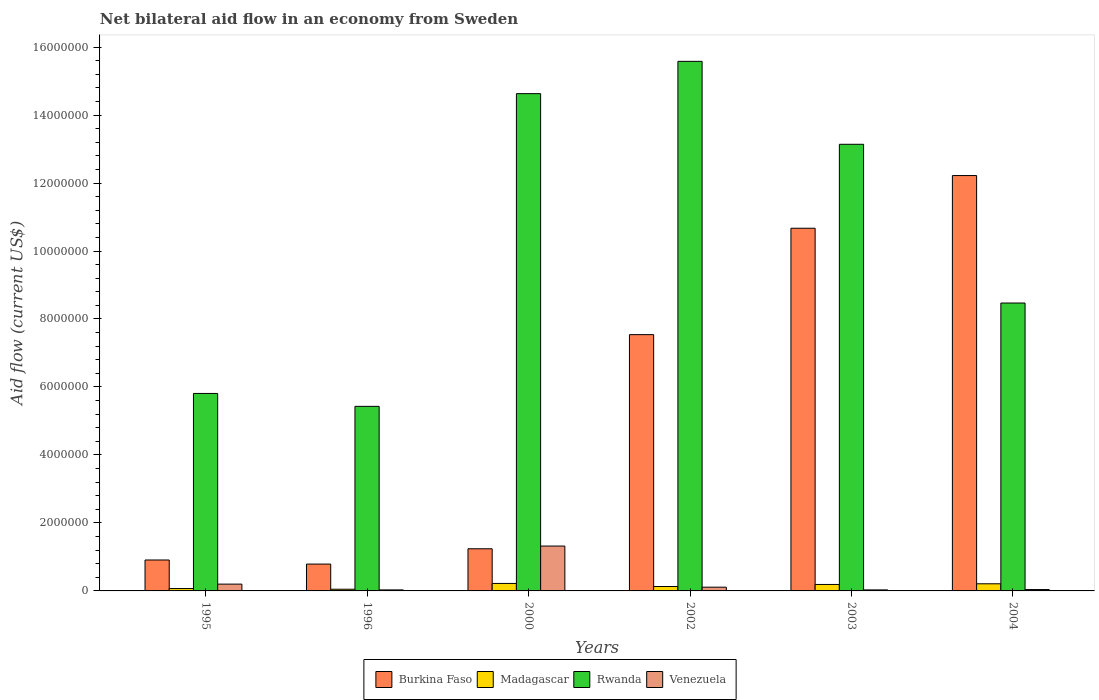How many groups of bars are there?
Provide a short and direct response. 6. Are the number of bars per tick equal to the number of legend labels?
Keep it short and to the point. Yes. Are the number of bars on each tick of the X-axis equal?
Your answer should be compact. Yes. What is the label of the 2nd group of bars from the left?
Your response must be concise. 1996. What is the net bilateral aid flow in Rwanda in 1995?
Your answer should be compact. 5.81e+06. Across all years, what is the maximum net bilateral aid flow in Venezuela?
Keep it short and to the point. 1.32e+06. Across all years, what is the minimum net bilateral aid flow in Rwanda?
Make the answer very short. 5.43e+06. In which year was the net bilateral aid flow in Madagascar maximum?
Your response must be concise. 2000. What is the total net bilateral aid flow in Burkina Faso in the graph?
Provide a succinct answer. 3.34e+07. What is the difference between the net bilateral aid flow in Venezuela in 2002 and that in 2003?
Your answer should be very brief. 8.00e+04. What is the difference between the net bilateral aid flow in Rwanda in 1996 and the net bilateral aid flow in Venezuela in 1995?
Offer a terse response. 5.23e+06. What is the average net bilateral aid flow in Venezuela per year?
Make the answer very short. 2.88e+05. In the year 2000, what is the difference between the net bilateral aid flow in Rwanda and net bilateral aid flow in Venezuela?
Keep it short and to the point. 1.33e+07. What is the ratio of the net bilateral aid flow in Madagascar in 1996 to that in 2000?
Make the answer very short. 0.23. Is the difference between the net bilateral aid flow in Rwanda in 1996 and 2003 greater than the difference between the net bilateral aid flow in Venezuela in 1996 and 2003?
Keep it short and to the point. No. What is the difference between the highest and the second highest net bilateral aid flow in Rwanda?
Offer a terse response. 9.50e+05. What is the difference between the highest and the lowest net bilateral aid flow in Madagascar?
Keep it short and to the point. 1.70e+05. What does the 2nd bar from the left in 2004 represents?
Your answer should be very brief. Madagascar. What does the 3rd bar from the right in 2002 represents?
Provide a short and direct response. Madagascar. Are all the bars in the graph horizontal?
Make the answer very short. No. What is the difference between two consecutive major ticks on the Y-axis?
Offer a terse response. 2.00e+06. Are the values on the major ticks of Y-axis written in scientific E-notation?
Your answer should be compact. No. Does the graph contain grids?
Offer a terse response. No. Where does the legend appear in the graph?
Your answer should be very brief. Bottom center. How are the legend labels stacked?
Offer a very short reply. Horizontal. What is the title of the graph?
Offer a very short reply. Net bilateral aid flow in an economy from Sweden. Does "World" appear as one of the legend labels in the graph?
Offer a very short reply. No. What is the label or title of the X-axis?
Make the answer very short. Years. What is the label or title of the Y-axis?
Provide a succinct answer. Aid flow (current US$). What is the Aid flow (current US$) of Burkina Faso in 1995?
Your response must be concise. 9.10e+05. What is the Aid flow (current US$) of Rwanda in 1995?
Your answer should be compact. 5.81e+06. What is the Aid flow (current US$) in Burkina Faso in 1996?
Provide a short and direct response. 7.90e+05. What is the Aid flow (current US$) of Rwanda in 1996?
Your answer should be very brief. 5.43e+06. What is the Aid flow (current US$) of Venezuela in 1996?
Your answer should be compact. 3.00e+04. What is the Aid flow (current US$) in Burkina Faso in 2000?
Ensure brevity in your answer.  1.24e+06. What is the Aid flow (current US$) in Madagascar in 2000?
Give a very brief answer. 2.20e+05. What is the Aid flow (current US$) of Rwanda in 2000?
Your answer should be very brief. 1.46e+07. What is the Aid flow (current US$) of Venezuela in 2000?
Offer a very short reply. 1.32e+06. What is the Aid flow (current US$) in Burkina Faso in 2002?
Your response must be concise. 7.54e+06. What is the Aid flow (current US$) of Rwanda in 2002?
Your answer should be very brief. 1.56e+07. What is the Aid flow (current US$) in Venezuela in 2002?
Offer a very short reply. 1.10e+05. What is the Aid flow (current US$) of Burkina Faso in 2003?
Ensure brevity in your answer.  1.07e+07. What is the Aid flow (current US$) of Rwanda in 2003?
Make the answer very short. 1.31e+07. What is the Aid flow (current US$) of Venezuela in 2003?
Provide a succinct answer. 3.00e+04. What is the Aid flow (current US$) of Burkina Faso in 2004?
Your answer should be compact. 1.22e+07. What is the Aid flow (current US$) of Madagascar in 2004?
Offer a terse response. 2.10e+05. What is the Aid flow (current US$) in Rwanda in 2004?
Provide a short and direct response. 8.47e+06. What is the Aid flow (current US$) in Venezuela in 2004?
Offer a very short reply. 4.00e+04. Across all years, what is the maximum Aid flow (current US$) of Burkina Faso?
Keep it short and to the point. 1.22e+07. Across all years, what is the maximum Aid flow (current US$) of Madagascar?
Keep it short and to the point. 2.20e+05. Across all years, what is the maximum Aid flow (current US$) of Rwanda?
Make the answer very short. 1.56e+07. Across all years, what is the maximum Aid flow (current US$) of Venezuela?
Your response must be concise. 1.32e+06. Across all years, what is the minimum Aid flow (current US$) in Burkina Faso?
Provide a succinct answer. 7.90e+05. Across all years, what is the minimum Aid flow (current US$) of Rwanda?
Offer a very short reply. 5.43e+06. What is the total Aid flow (current US$) in Burkina Faso in the graph?
Offer a very short reply. 3.34e+07. What is the total Aid flow (current US$) in Madagascar in the graph?
Provide a short and direct response. 8.70e+05. What is the total Aid flow (current US$) of Rwanda in the graph?
Offer a terse response. 6.31e+07. What is the total Aid flow (current US$) in Venezuela in the graph?
Ensure brevity in your answer.  1.73e+06. What is the difference between the Aid flow (current US$) in Burkina Faso in 1995 and that in 1996?
Provide a succinct answer. 1.20e+05. What is the difference between the Aid flow (current US$) in Venezuela in 1995 and that in 1996?
Offer a terse response. 1.70e+05. What is the difference between the Aid flow (current US$) in Burkina Faso in 1995 and that in 2000?
Ensure brevity in your answer.  -3.30e+05. What is the difference between the Aid flow (current US$) in Rwanda in 1995 and that in 2000?
Offer a terse response. -8.82e+06. What is the difference between the Aid flow (current US$) of Venezuela in 1995 and that in 2000?
Provide a succinct answer. -1.12e+06. What is the difference between the Aid flow (current US$) in Burkina Faso in 1995 and that in 2002?
Your answer should be compact. -6.63e+06. What is the difference between the Aid flow (current US$) in Rwanda in 1995 and that in 2002?
Your response must be concise. -9.77e+06. What is the difference between the Aid flow (current US$) in Burkina Faso in 1995 and that in 2003?
Provide a succinct answer. -9.76e+06. What is the difference between the Aid flow (current US$) of Madagascar in 1995 and that in 2003?
Ensure brevity in your answer.  -1.20e+05. What is the difference between the Aid flow (current US$) in Rwanda in 1995 and that in 2003?
Ensure brevity in your answer.  -7.33e+06. What is the difference between the Aid flow (current US$) of Burkina Faso in 1995 and that in 2004?
Your answer should be very brief. -1.13e+07. What is the difference between the Aid flow (current US$) of Rwanda in 1995 and that in 2004?
Offer a terse response. -2.66e+06. What is the difference between the Aid flow (current US$) in Venezuela in 1995 and that in 2004?
Provide a succinct answer. 1.60e+05. What is the difference between the Aid flow (current US$) in Burkina Faso in 1996 and that in 2000?
Offer a terse response. -4.50e+05. What is the difference between the Aid flow (current US$) of Rwanda in 1996 and that in 2000?
Give a very brief answer. -9.20e+06. What is the difference between the Aid flow (current US$) of Venezuela in 1996 and that in 2000?
Your response must be concise. -1.29e+06. What is the difference between the Aid flow (current US$) of Burkina Faso in 1996 and that in 2002?
Offer a terse response. -6.75e+06. What is the difference between the Aid flow (current US$) of Madagascar in 1996 and that in 2002?
Offer a very short reply. -8.00e+04. What is the difference between the Aid flow (current US$) in Rwanda in 1996 and that in 2002?
Ensure brevity in your answer.  -1.02e+07. What is the difference between the Aid flow (current US$) in Venezuela in 1996 and that in 2002?
Provide a short and direct response. -8.00e+04. What is the difference between the Aid flow (current US$) of Burkina Faso in 1996 and that in 2003?
Give a very brief answer. -9.88e+06. What is the difference between the Aid flow (current US$) of Madagascar in 1996 and that in 2003?
Provide a short and direct response. -1.40e+05. What is the difference between the Aid flow (current US$) of Rwanda in 1996 and that in 2003?
Provide a short and direct response. -7.71e+06. What is the difference between the Aid flow (current US$) in Venezuela in 1996 and that in 2003?
Offer a very short reply. 0. What is the difference between the Aid flow (current US$) in Burkina Faso in 1996 and that in 2004?
Keep it short and to the point. -1.14e+07. What is the difference between the Aid flow (current US$) in Rwanda in 1996 and that in 2004?
Provide a succinct answer. -3.04e+06. What is the difference between the Aid flow (current US$) of Burkina Faso in 2000 and that in 2002?
Ensure brevity in your answer.  -6.30e+06. What is the difference between the Aid flow (current US$) in Madagascar in 2000 and that in 2002?
Keep it short and to the point. 9.00e+04. What is the difference between the Aid flow (current US$) in Rwanda in 2000 and that in 2002?
Provide a short and direct response. -9.50e+05. What is the difference between the Aid flow (current US$) of Venezuela in 2000 and that in 2002?
Offer a very short reply. 1.21e+06. What is the difference between the Aid flow (current US$) of Burkina Faso in 2000 and that in 2003?
Keep it short and to the point. -9.43e+06. What is the difference between the Aid flow (current US$) of Madagascar in 2000 and that in 2003?
Give a very brief answer. 3.00e+04. What is the difference between the Aid flow (current US$) in Rwanda in 2000 and that in 2003?
Make the answer very short. 1.49e+06. What is the difference between the Aid flow (current US$) of Venezuela in 2000 and that in 2003?
Your answer should be very brief. 1.29e+06. What is the difference between the Aid flow (current US$) in Burkina Faso in 2000 and that in 2004?
Provide a short and direct response. -1.10e+07. What is the difference between the Aid flow (current US$) in Madagascar in 2000 and that in 2004?
Your answer should be very brief. 10000. What is the difference between the Aid flow (current US$) in Rwanda in 2000 and that in 2004?
Keep it short and to the point. 6.16e+06. What is the difference between the Aid flow (current US$) of Venezuela in 2000 and that in 2004?
Make the answer very short. 1.28e+06. What is the difference between the Aid flow (current US$) in Burkina Faso in 2002 and that in 2003?
Offer a very short reply. -3.13e+06. What is the difference between the Aid flow (current US$) of Rwanda in 2002 and that in 2003?
Your answer should be compact. 2.44e+06. What is the difference between the Aid flow (current US$) of Burkina Faso in 2002 and that in 2004?
Offer a very short reply. -4.68e+06. What is the difference between the Aid flow (current US$) in Madagascar in 2002 and that in 2004?
Your answer should be compact. -8.00e+04. What is the difference between the Aid flow (current US$) of Rwanda in 2002 and that in 2004?
Provide a short and direct response. 7.11e+06. What is the difference between the Aid flow (current US$) of Burkina Faso in 2003 and that in 2004?
Make the answer very short. -1.55e+06. What is the difference between the Aid flow (current US$) of Madagascar in 2003 and that in 2004?
Ensure brevity in your answer.  -2.00e+04. What is the difference between the Aid flow (current US$) in Rwanda in 2003 and that in 2004?
Provide a short and direct response. 4.67e+06. What is the difference between the Aid flow (current US$) of Burkina Faso in 1995 and the Aid flow (current US$) of Madagascar in 1996?
Offer a terse response. 8.60e+05. What is the difference between the Aid flow (current US$) of Burkina Faso in 1995 and the Aid flow (current US$) of Rwanda in 1996?
Your answer should be very brief. -4.52e+06. What is the difference between the Aid flow (current US$) of Burkina Faso in 1995 and the Aid flow (current US$) of Venezuela in 1996?
Your answer should be compact. 8.80e+05. What is the difference between the Aid flow (current US$) of Madagascar in 1995 and the Aid flow (current US$) of Rwanda in 1996?
Provide a succinct answer. -5.36e+06. What is the difference between the Aid flow (current US$) of Rwanda in 1995 and the Aid flow (current US$) of Venezuela in 1996?
Provide a short and direct response. 5.78e+06. What is the difference between the Aid flow (current US$) of Burkina Faso in 1995 and the Aid flow (current US$) of Madagascar in 2000?
Provide a succinct answer. 6.90e+05. What is the difference between the Aid flow (current US$) in Burkina Faso in 1995 and the Aid flow (current US$) in Rwanda in 2000?
Your answer should be very brief. -1.37e+07. What is the difference between the Aid flow (current US$) of Burkina Faso in 1995 and the Aid flow (current US$) of Venezuela in 2000?
Your response must be concise. -4.10e+05. What is the difference between the Aid flow (current US$) in Madagascar in 1995 and the Aid flow (current US$) in Rwanda in 2000?
Give a very brief answer. -1.46e+07. What is the difference between the Aid flow (current US$) of Madagascar in 1995 and the Aid flow (current US$) of Venezuela in 2000?
Provide a succinct answer. -1.25e+06. What is the difference between the Aid flow (current US$) in Rwanda in 1995 and the Aid flow (current US$) in Venezuela in 2000?
Your answer should be compact. 4.49e+06. What is the difference between the Aid flow (current US$) in Burkina Faso in 1995 and the Aid flow (current US$) in Madagascar in 2002?
Offer a terse response. 7.80e+05. What is the difference between the Aid flow (current US$) in Burkina Faso in 1995 and the Aid flow (current US$) in Rwanda in 2002?
Provide a short and direct response. -1.47e+07. What is the difference between the Aid flow (current US$) of Madagascar in 1995 and the Aid flow (current US$) of Rwanda in 2002?
Keep it short and to the point. -1.55e+07. What is the difference between the Aid flow (current US$) in Madagascar in 1995 and the Aid flow (current US$) in Venezuela in 2002?
Make the answer very short. -4.00e+04. What is the difference between the Aid flow (current US$) of Rwanda in 1995 and the Aid flow (current US$) of Venezuela in 2002?
Ensure brevity in your answer.  5.70e+06. What is the difference between the Aid flow (current US$) of Burkina Faso in 1995 and the Aid flow (current US$) of Madagascar in 2003?
Your answer should be compact. 7.20e+05. What is the difference between the Aid flow (current US$) in Burkina Faso in 1995 and the Aid flow (current US$) in Rwanda in 2003?
Provide a succinct answer. -1.22e+07. What is the difference between the Aid flow (current US$) of Burkina Faso in 1995 and the Aid flow (current US$) of Venezuela in 2003?
Your response must be concise. 8.80e+05. What is the difference between the Aid flow (current US$) in Madagascar in 1995 and the Aid flow (current US$) in Rwanda in 2003?
Give a very brief answer. -1.31e+07. What is the difference between the Aid flow (current US$) in Madagascar in 1995 and the Aid flow (current US$) in Venezuela in 2003?
Your answer should be very brief. 4.00e+04. What is the difference between the Aid flow (current US$) in Rwanda in 1995 and the Aid flow (current US$) in Venezuela in 2003?
Your answer should be compact. 5.78e+06. What is the difference between the Aid flow (current US$) of Burkina Faso in 1995 and the Aid flow (current US$) of Madagascar in 2004?
Offer a terse response. 7.00e+05. What is the difference between the Aid flow (current US$) in Burkina Faso in 1995 and the Aid flow (current US$) in Rwanda in 2004?
Give a very brief answer. -7.56e+06. What is the difference between the Aid flow (current US$) in Burkina Faso in 1995 and the Aid flow (current US$) in Venezuela in 2004?
Give a very brief answer. 8.70e+05. What is the difference between the Aid flow (current US$) of Madagascar in 1995 and the Aid flow (current US$) of Rwanda in 2004?
Keep it short and to the point. -8.40e+06. What is the difference between the Aid flow (current US$) in Madagascar in 1995 and the Aid flow (current US$) in Venezuela in 2004?
Provide a succinct answer. 3.00e+04. What is the difference between the Aid flow (current US$) of Rwanda in 1995 and the Aid flow (current US$) of Venezuela in 2004?
Your answer should be very brief. 5.77e+06. What is the difference between the Aid flow (current US$) of Burkina Faso in 1996 and the Aid flow (current US$) of Madagascar in 2000?
Your answer should be compact. 5.70e+05. What is the difference between the Aid flow (current US$) in Burkina Faso in 1996 and the Aid flow (current US$) in Rwanda in 2000?
Keep it short and to the point. -1.38e+07. What is the difference between the Aid flow (current US$) in Burkina Faso in 1996 and the Aid flow (current US$) in Venezuela in 2000?
Provide a short and direct response. -5.30e+05. What is the difference between the Aid flow (current US$) in Madagascar in 1996 and the Aid flow (current US$) in Rwanda in 2000?
Make the answer very short. -1.46e+07. What is the difference between the Aid flow (current US$) in Madagascar in 1996 and the Aid flow (current US$) in Venezuela in 2000?
Offer a very short reply. -1.27e+06. What is the difference between the Aid flow (current US$) in Rwanda in 1996 and the Aid flow (current US$) in Venezuela in 2000?
Provide a short and direct response. 4.11e+06. What is the difference between the Aid flow (current US$) in Burkina Faso in 1996 and the Aid flow (current US$) in Madagascar in 2002?
Provide a succinct answer. 6.60e+05. What is the difference between the Aid flow (current US$) in Burkina Faso in 1996 and the Aid flow (current US$) in Rwanda in 2002?
Provide a succinct answer. -1.48e+07. What is the difference between the Aid flow (current US$) in Burkina Faso in 1996 and the Aid flow (current US$) in Venezuela in 2002?
Ensure brevity in your answer.  6.80e+05. What is the difference between the Aid flow (current US$) of Madagascar in 1996 and the Aid flow (current US$) of Rwanda in 2002?
Provide a short and direct response. -1.55e+07. What is the difference between the Aid flow (current US$) in Rwanda in 1996 and the Aid flow (current US$) in Venezuela in 2002?
Provide a succinct answer. 5.32e+06. What is the difference between the Aid flow (current US$) in Burkina Faso in 1996 and the Aid flow (current US$) in Rwanda in 2003?
Provide a short and direct response. -1.24e+07. What is the difference between the Aid flow (current US$) of Burkina Faso in 1996 and the Aid flow (current US$) of Venezuela in 2003?
Ensure brevity in your answer.  7.60e+05. What is the difference between the Aid flow (current US$) in Madagascar in 1996 and the Aid flow (current US$) in Rwanda in 2003?
Your answer should be very brief. -1.31e+07. What is the difference between the Aid flow (current US$) in Rwanda in 1996 and the Aid flow (current US$) in Venezuela in 2003?
Your answer should be very brief. 5.40e+06. What is the difference between the Aid flow (current US$) in Burkina Faso in 1996 and the Aid flow (current US$) in Madagascar in 2004?
Your answer should be compact. 5.80e+05. What is the difference between the Aid flow (current US$) in Burkina Faso in 1996 and the Aid flow (current US$) in Rwanda in 2004?
Ensure brevity in your answer.  -7.68e+06. What is the difference between the Aid flow (current US$) of Burkina Faso in 1996 and the Aid flow (current US$) of Venezuela in 2004?
Keep it short and to the point. 7.50e+05. What is the difference between the Aid flow (current US$) in Madagascar in 1996 and the Aid flow (current US$) in Rwanda in 2004?
Give a very brief answer. -8.42e+06. What is the difference between the Aid flow (current US$) of Rwanda in 1996 and the Aid flow (current US$) of Venezuela in 2004?
Your response must be concise. 5.39e+06. What is the difference between the Aid flow (current US$) in Burkina Faso in 2000 and the Aid flow (current US$) in Madagascar in 2002?
Your answer should be very brief. 1.11e+06. What is the difference between the Aid flow (current US$) in Burkina Faso in 2000 and the Aid flow (current US$) in Rwanda in 2002?
Provide a short and direct response. -1.43e+07. What is the difference between the Aid flow (current US$) in Burkina Faso in 2000 and the Aid flow (current US$) in Venezuela in 2002?
Your response must be concise. 1.13e+06. What is the difference between the Aid flow (current US$) of Madagascar in 2000 and the Aid flow (current US$) of Rwanda in 2002?
Keep it short and to the point. -1.54e+07. What is the difference between the Aid flow (current US$) of Rwanda in 2000 and the Aid flow (current US$) of Venezuela in 2002?
Ensure brevity in your answer.  1.45e+07. What is the difference between the Aid flow (current US$) of Burkina Faso in 2000 and the Aid flow (current US$) of Madagascar in 2003?
Offer a very short reply. 1.05e+06. What is the difference between the Aid flow (current US$) in Burkina Faso in 2000 and the Aid flow (current US$) in Rwanda in 2003?
Provide a succinct answer. -1.19e+07. What is the difference between the Aid flow (current US$) in Burkina Faso in 2000 and the Aid flow (current US$) in Venezuela in 2003?
Offer a terse response. 1.21e+06. What is the difference between the Aid flow (current US$) in Madagascar in 2000 and the Aid flow (current US$) in Rwanda in 2003?
Offer a terse response. -1.29e+07. What is the difference between the Aid flow (current US$) in Madagascar in 2000 and the Aid flow (current US$) in Venezuela in 2003?
Your answer should be compact. 1.90e+05. What is the difference between the Aid flow (current US$) in Rwanda in 2000 and the Aid flow (current US$) in Venezuela in 2003?
Offer a very short reply. 1.46e+07. What is the difference between the Aid flow (current US$) in Burkina Faso in 2000 and the Aid flow (current US$) in Madagascar in 2004?
Provide a succinct answer. 1.03e+06. What is the difference between the Aid flow (current US$) in Burkina Faso in 2000 and the Aid flow (current US$) in Rwanda in 2004?
Your answer should be compact. -7.23e+06. What is the difference between the Aid flow (current US$) of Burkina Faso in 2000 and the Aid flow (current US$) of Venezuela in 2004?
Ensure brevity in your answer.  1.20e+06. What is the difference between the Aid flow (current US$) of Madagascar in 2000 and the Aid flow (current US$) of Rwanda in 2004?
Provide a succinct answer. -8.25e+06. What is the difference between the Aid flow (current US$) in Madagascar in 2000 and the Aid flow (current US$) in Venezuela in 2004?
Your answer should be very brief. 1.80e+05. What is the difference between the Aid flow (current US$) in Rwanda in 2000 and the Aid flow (current US$) in Venezuela in 2004?
Your answer should be compact. 1.46e+07. What is the difference between the Aid flow (current US$) in Burkina Faso in 2002 and the Aid flow (current US$) in Madagascar in 2003?
Your response must be concise. 7.35e+06. What is the difference between the Aid flow (current US$) of Burkina Faso in 2002 and the Aid flow (current US$) of Rwanda in 2003?
Offer a very short reply. -5.60e+06. What is the difference between the Aid flow (current US$) in Burkina Faso in 2002 and the Aid flow (current US$) in Venezuela in 2003?
Make the answer very short. 7.51e+06. What is the difference between the Aid flow (current US$) in Madagascar in 2002 and the Aid flow (current US$) in Rwanda in 2003?
Offer a very short reply. -1.30e+07. What is the difference between the Aid flow (current US$) in Rwanda in 2002 and the Aid flow (current US$) in Venezuela in 2003?
Provide a succinct answer. 1.56e+07. What is the difference between the Aid flow (current US$) in Burkina Faso in 2002 and the Aid flow (current US$) in Madagascar in 2004?
Keep it short and to the point. 7.33e+06. What is the difference between the Aid flow (current US$) of Burkina Faso in 2002 and the Aid flow (current US$) of Rwanda in 2004?
Keep it short and to the point. -9.30e+05. What is the difference between the Aid flow (current US$) in Burkina Faso in 2002 and the Aid flow (current US$) in Venezuela in 2004?
Offer a terse response. 7.50e+06. What is the difference between the Aid flow (current US$) in Madagascar in 2002 and the Aid flow (current US$) in Rwanda in 2004?
Provide a succinct answer. -8.34e+06. What is the difference between the Aid flow (current US$) in Rwanda in 2002 and the Aid flow (current US$) in Venezuela in 2004?
Your answer should be compact. 1.55e+07. What is the difference between the Aid flow (current US$) in Burkina Faso in 2003 and the Aid flow (current US$) in Madagascar in 2004?
Keep it short and to the point. 1.05e+07. What is the difference between the Aid flow (current US$) in Burkina Faso in 2003 and the Aid flow (current US$) in Rwanda in 2004?
Offer a terse response. 2.20e+06. What is the difference between the Aid flow (current US$) of Burkina Faso in 2003 and the Aid flow (current US$) of Venezuela in 2004?
Your response must be concise. 1.06e+07. What is the difference between the Aid flow (current US$) in Madagascar in 2003 and the Aid flow (current US$) in Rwanda in 2004?
Your response must be concise. -8.28e+06. What is the difference between the Aid flow (current US$) of Madagascar in 2003 and the Aid flow (current US$) of Venezuela in 2004?
Give a very brief answer. 1.50e+05. What is the difference between the Aid flow (current US$) in Rwanda in 2003 and the Aid flow (current US$) in Venezuela in 2004?
Provide a short and direct response. 1.31e+07. What is the average Aid flow (current US$) in Burkina Faso per year?
Give a very brief answer. 5.56e+06. What is the average Aid flow (current US$) in Madagascar per year?
Your answer should be compact. 1.45e+05. What is the average Aid flow (current US$) in Rwanda per year?
Your answer should be compact. 1.05e+07. What is the average Aid flow (current US$) of Venezuela per year?
Your answer should be very brief. 2.88e+05. In the year 1995, what is the difference between the Aid flow (current US$) in Burkina Faso and Aid flow (current US$) in Madagascar?
Provide a short and direct response. 8.40e+05. In the year 1995, what is the difference between the Aid flow (current US$) in Burkina Faso and Aid flow (current US$) in Rwanda?
Ensure brevity in your answer.  -4.90e+06. In the year 1995, what is the difference between the Aid flow (current US$) in Burkina Faso and Aid flow (current US$) in Venezuela?
Provide a short and direct response. 7.10e+05. In the year 1995, what is the difference between the Aid flow (current US$) of Madagascar and Aid flow (current US$) of Rwanda?
Offer a terse response. -5.74e+06. In the year 1995, what is the difference between the Aid flow (current US$) in Rwanda and Aid flow (current US$) in Venezuela?
Give a very brief answer. 5.61e+06. In the year 1996, what is the difference between the Aid flow (current US$) of Burkina Faso and Aid flow (current US$) of Madagascar?
Your answer should be very brief. 7.40e+05. In the year 1996, what is the difference between the Aid flow (current US$) of Burkina Faso and Aid flow (current US$) of Rwanda?
Ensure brevity in your answer.  -4.64e+06. In the year 1996, what is the difference between the Aid flow (current US$) of Burkina Faso and Aid flow (current US$) of Venezuela?
Ensure brevity in your answer.  7.60e+05. In the year 1996, what is the difference between the Aid flow (current US$) of Madagascar and Aid flow (current US$) of Rwanda?
Make the answer very short. -5.38e+06. In the year 1996, what is the difference between the Aid flow (current US$) of Madagascar and Aid flow (current US$) of Venezuela?
Provide a succinct answer. 2.00e+04. In the year 1996, what is the difference between the Aid flow (current US$) in Rwanda and Aid flow (current US$) in Venezuela?
Provide a short and direct response. 5.40e+06. In the year 2000, what is the difference between the Aid flow (current US$) of Burkina Faso and Aid flow (current US$) of Madagascar?
Your response must be concise. 1.02e+06. In the year 2000, what is the difference between the Aid flow (current US$) in Burkina Faso and Aid flow (current US$) in Rwanda?
Keep it short and to the point. -1.34e+07. In the year 2000, what is the difference between the Aid flow (current US$) in Burkina Faso and Aid flow (current US$) in Venezuela?
Your answer should be very brief. -8.00e+04. In the year 2000, what is the difference between the Aid flow (current US$) of Madagascar and Aid flow (current US$) of Rwanda?
Keep it short and to the point. -1.44e+07. In the year 2000, what is the difference between the Aid flow (current US$) in Madagascar and Aid flow (current US$) in Venezuela?
Your answer should be compact. -1.10e+06. In the year 2000, what is the difference between the Aid flow (current US$) of Rwanda and Aid flow (current US$) of Venezuela?
Offer a very short reply. 1.33e+07. In the year 2002, what is the difference between the Aid flow (current US$) of Burkina Faso and Aid flow (current US$) of Madagascar?
Give a very brief answer. 7.41e+06. In the year 2002, what is the difference between the Aid flow (current US$) in Burkina Faso and Aid flow (current US$) in Rwanda?
Offer a very short reply. -8.04e+06. In the year 2002, what is the difference between the Aid flow (current US$) of Burkina Faso and Aid flow (current US$) of Venezuela?
Make the answer very short. 7.43e+06. In the year 2002, what is the difference between the Aid flow (current US$) of Madagascar and Aid flow (current US$) of Rwanda?
Make the answer very short. -1.54e+07. In the year 2002, what is the difference between the Aid flow (current US$) in Rwanda and Aid flow (current US$) in Venezuela?
Your answer should be compact. 1.55e+07. In the year 2003, what is the difference between the Aid flow (current US$) in Burkina Faso and Aid flow (current US$) in Madagascar?
Offer a very short reply. 1.05e+07. In the year 2003, what is the difference between the Aid flow (current US$) in Burkina Faso and Aid flow (current US$) in Rwanda?
Your response must be concise. -2.47e+06. In the year 2003, what is the difference between the Aid flow (current US$) in Burkina Faso and Aid flow (current US$) in Venezuela?
Provide a short and direct response. 1.06e+07. In the year 2003, what is the difference between the Aid flow (current US$) in Madagascar and Aid flow (current US$) in Rwanda?
Provide a succinct answer. -1.30e+07. In the year 2003, what is the difference between the Aid flow (current US$) of Madagascar and Aid flow (current US$) of Venezuela?
Give a very brief answer. 1.60e+05. In the year 2003, what is the difference between the Aid flow (current US$) in Rwanda and Aid flow (current US$) in Venezuela?
Offer a terse response. 1.31e+07. In the year 2004, what is the difference between the Aid flow (current US$) in Burkina Faso and Aid flow (current US$) in Madagascar?
Offer a very short reply. 1.20e+07. In the year 2004, what is the difference between the Aid flow (current US$) in Burkina Faso and Aid flow (current US$) in Rwanda?
Provide a short and direct response. 3.75e+06. In the year 2004, what is the difference between the Aid flow (current US$) in Burkina Faso and Aid flow (current US$) in Venezuela?
Provide a succinct answer. 1.22e+07. In the year 2004, what is the difference between the Aid flow (current US$) in Madagascar and Aid flow (current US$) in Rwanda?
Provide a short and direct response. -8.26e+06. In the year 2004, what is the difference between the Aid flow (current US$) in Madagascar and Aid flow (current US$) in Venezuela?
Provide a succinct answer. 1.70e+05. In the year 2004, what is the difference between the Aid flow (current US$) of Rwanda and Aid flow (current US$) of Venezuela?
Offer a terse response. 8.43e+06. What is the ratio of the Aid flow (current US$) in Burkina Faso in 1995 to that in 1996?
Make the answer very short. 1.15. What is the ratio of the Aid flow (current US$) in Madagascar in 1995 to that in 1996?
Provide a short and direct response. 1.4. What is the ratio of the Aid flow (current US$) of Rwanda in 1995 to that in 1996?
Offer a very short reply. 1.07. What is the ratio of the Aid flow (current US$) of Burkina Faso in 1995 to that in 2000?
Your answer should be compact. 0.73. What is the ratio of the Aid flow (current US$) of Madagascar in 1995 to that in 2000?
Give a very brief answer. 0.32. What is the ratio of the Aid flow (current US$) in Rwanda in 1995 to that in 2000?
Your response must be concise. 0.4. What is the ratio of the Aid flow (current US$) of Venezuela in 1995 to that in 2000?
Offer a very short reply. 0.15. What is the ratio of the Aid flow (current US$) of Burkina Faso in 1995 to that in 2002?
Provide a short and direct response. 0.12. What is the ratio of the Aid flow (current US$) in Madagascar in 1995 to that in 2002?
Your response must be concise. 0.54. What is the ratio of the Aid flow (current US$) of Rwanda in 1995 to that in 2002?
Offer a very short reply. 0.37. What is the ratio of the Aid flow (current US$) in Venezuela in 1995 to that in 2002?
Keep it short and to the point. 1.82. What is the ratio of the Aid flow (current US$) of Burkina Faso in 1995 to that in 2003?
Provide a short and direct response. 0.09. What is the ratio of the Aid flow (current US$) in Madagascar in 1995 to that in 2003?
Make the answer very short. 0.37. What is the ratio of the Aid flow (current US$) in Rwanda in 1995 to that in 2003?
Offer a very short reply. 0.44. What is the ratio of the Aid flow (current US$) in Venezuela in 1995 to that in 2003?
Offer a terse response. 6.67. What is the ratio of the Aid flow (current US$) of Burkina Faso in 1995 to that in 2004?
Your answer should be compact. 0.07. What is the ratio of the Aid flow (current US$) of Rwanda in 1995 to that in 2004?
Your answer should be compact. 0.69. What is the ratio of the Aid flow (current US$) in Venezuela in 1995 to that in 2004?
Provide a short and direct response. 5. What is the ratio of the Aid flow (current US$) in Burkina Faso in 1996 to that in 2000?
Your answer should be very brief. 0.64. What is the ratio of the Aid flow (current US$) in Madagascar in 1996 to that in 2000?
Give a very brief answer. 0.23. What is the ratio of the Aid flow (current US$) in Rwanda in 1996 to that in 2000?
Your answer should be very brief. 0.37. What is the ratio of the Aid flow (current US$) in Venezuela in 1996 to that in 2000?
Offer a terse response. 0.02. What is the ratio of the Aid flow (current US$) of Burkina Faso in 1996 to that in 2002?
Offer a terse response. 0.1. What is the ratio of the Aid flow (current US$) of Madagascar in 1996 to that in 2002?
Give a very brief answer. 0.38. What is the ratio of the Aid flow (current US$) of Rwanda in 1996 to that in 2002?
Keep it short and to the point. 0.35. What is the ratio of the Aid flow (current US$) in Venezuela in 1996 to that in 2002?
Provide a succinct answer. 0.27. What is the ratio of the Aid flow (current US$) of Burkina Faso in 1996 to that in 2003?
Provide a short and direct response. 0.07. What is the ratio of the Aid flow (current US$) of Madagascar in 1996 to that in 2003?
Offer a terse response. 0.26. What is the ratio of the Aid flow (current US$) of Rwanda in 1996 to that in 2003?
Keep it short and to the point. 0.41. What is the ratio of the Aid flow (current US$) of Burkina Faso in 1996 to that in 2004?
Offer a terse response. 0.06. What is the ratio of the Aid flow (current US$) in Madagascar in 1996 to that in 2004?
Your answer should be compact. 0.24. What is the ratio of the Aid flow (current US$) in Rwanda in 1996 to that in 2004?
Keep it short and to the point. 0.64. What is the ratio of the Aid flow (current US$) in Burkina Faso in 2000 to that in 2002?
Keep it short and to the point. 0.16. What is the ratio of the Aid flow (current US$) in Madagascar in 2000 to that in 2002?
Ensure brevity in your answer.  1.69. What is the ratio of the Aid flow (current US$) of Rwanda in 2000 to that in 2002?
Your response must be concise. 0.94. What is the ratio of the Aid flow (current US$) in Venezuela in 2000 to that in 2002?
Give a very brief answer. 12. What is the ratio of the Aid flow (current US$) of Burkina Faso in 2000 to that in 2003?
Provide a succinct answer. 0.12. What is the ratio of the Aid flow (current US$) of Madagascar in 2000 to that in 2003?
Offer a terse response. 1.16. What is the ratio of the Aid flow (current US$) of Rwanda in 2000 to that in 2003?
Make the answer very short. 1.11. What is the ratio of the Aid flow (current US$) in Burkina Faso in 2000 to that in 2004?
Your answer should be very brief. 0.1. What is the ratio of the Aid flow (current US$) in Madagascar in 2000 to that in 2004?
Give a very brief answer. 1.05. What is the ratio of the Aid flow (current US$) in Rwanda in 2000 to that in 2004?
Give a very brief answer. 1.73. What is the ratio of the Aid flow (current US$) of Venezuela in 2000 to that in 2004?
Ensure brevity in your answer.  33. What is the ratio of the Aid flow (current US$) of Burkina Faso in 2002 to that in 2003?
Provide a short and direct response. 0.71. What is the ratio of the Aid flow (current US$) in Madagascar in 2002 to that in 2003?
Make the answer very short. 0.68. What is the ratio of the Aid flow (current US$) of Rwanda in 2002 to that in 2003?
Your response must be concise. 1.19. What is the ratio of the Aid flow (current US$) in Venezuela in 2002 to that in 2003?
Make the answer very short. 3.67. What is the ratio of the Aid flow (current US$) in Burkina Faso in 2002 to that in 2004?
Provide a short and direct response. 0.62. What is the ratio of the Aid flow (current US$) in Madagascar in 2002 to that in 2004?
Your answer should be compact. 0.62. What is the ratio of the Aid flow (current US$) in Rwanda in 2002 to that in 2004?
Make the answer very short. 1.84. What is the ratio of the Aid flow (current US$) of Venezuela in 2002 to that in 2004?
Provide a succinct answer. 2.75. What is the ratio of the Aid flow (current US$) of Burkina Faso in 2003 to that in 2004?
Provide a succinct answer. 0.87. What is the ratio of the Aid flow (current US$) in Madagascar in 2003 to that in 2004?
Your answer should be very brief. 0.9. What is the ratio of the Aid flow (current US$) of Rwanda in 2003 to that in 2004?
Your answer should be compact. 1.55. What is the difference between the highest and the second highest Aid flow (current US$) in Burkina Faso?
Keep it short and to the point. 1.55e+06. What is the difference between the highest and the second highest Aid flow (current US$) in Madagascar?
Ensure brevity in your answer.  10000. What is the difference between the highest and the second highest Aid flow (current US$) of Rwanda?
Provide a short and direct response. 9.50e+05. What is the difference between the highest and the second highest Aid flow (current US$) of Venezuela?
Make the answer very short. 1.12e+06. What is the difference between the highest and the lowest Aid flow (current US$) in Burkina Faso?
Your answer should be compact. 1.14e+07. What is the difference between the highest and the lowest Aid flow (current US$) of Madagascar?
Your response must be concise. 1.70e+05. What is the difference between the highest and the lowest Aid flow (current US$) in Rwanda?
Ensure brevity in your answer.  1.02e+07. What is the difference between the highest and the lowest Aid flow (current US$) of Venezuela?
Keep it short and to the point. 1.29e+06. 